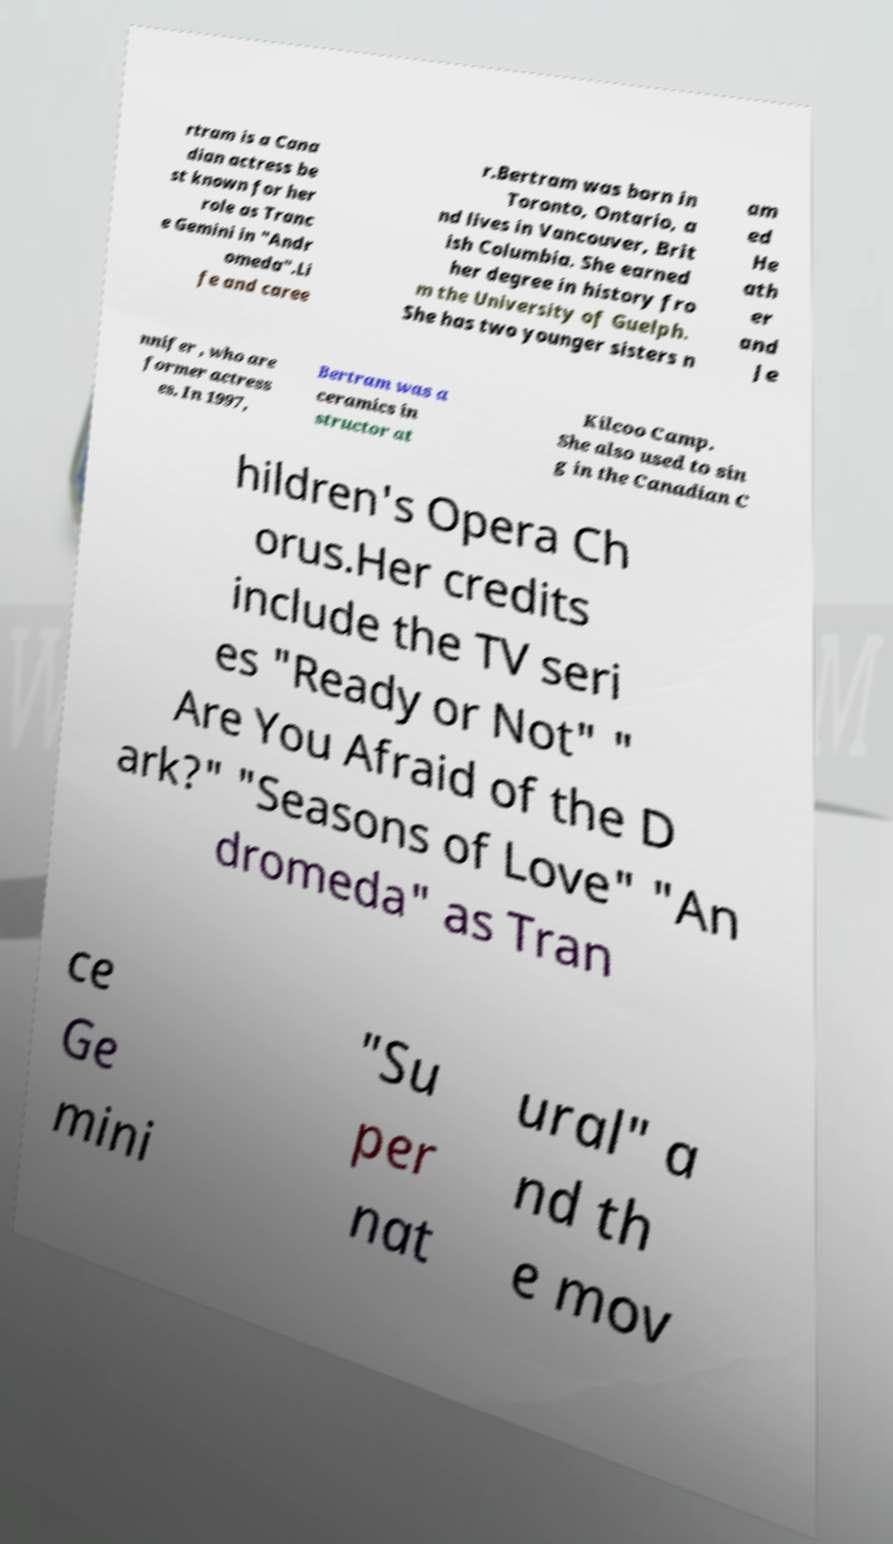There's text embedded in this image that I need extracted. Can you transcribe it verbatim? rtram is a Cana dian actress be st known for her role as Tranc e Gemini in "Andr omeda".Li fe and caree r.Bertram was born in Toronto, Ontario, a nd lives in Vancouver, Brit ish Columbia. She earned her degree in history fro m the University of Guelph. She has two younger sisters n am ed He ath er and Je nnifer , who are former actress es. In 1997, Bertram was a ceramics in structor at Kilcoo Camp. She also used to sin g in the Canadian C hildren's Opera Ch orus.Her credits include the TV seri es "Ready or Not" " Are You Afraid of the D ark?" "Seasons of Love" "An dromeda" as Tran ce Ge mini "Su per nat ural" a nd th e mov 